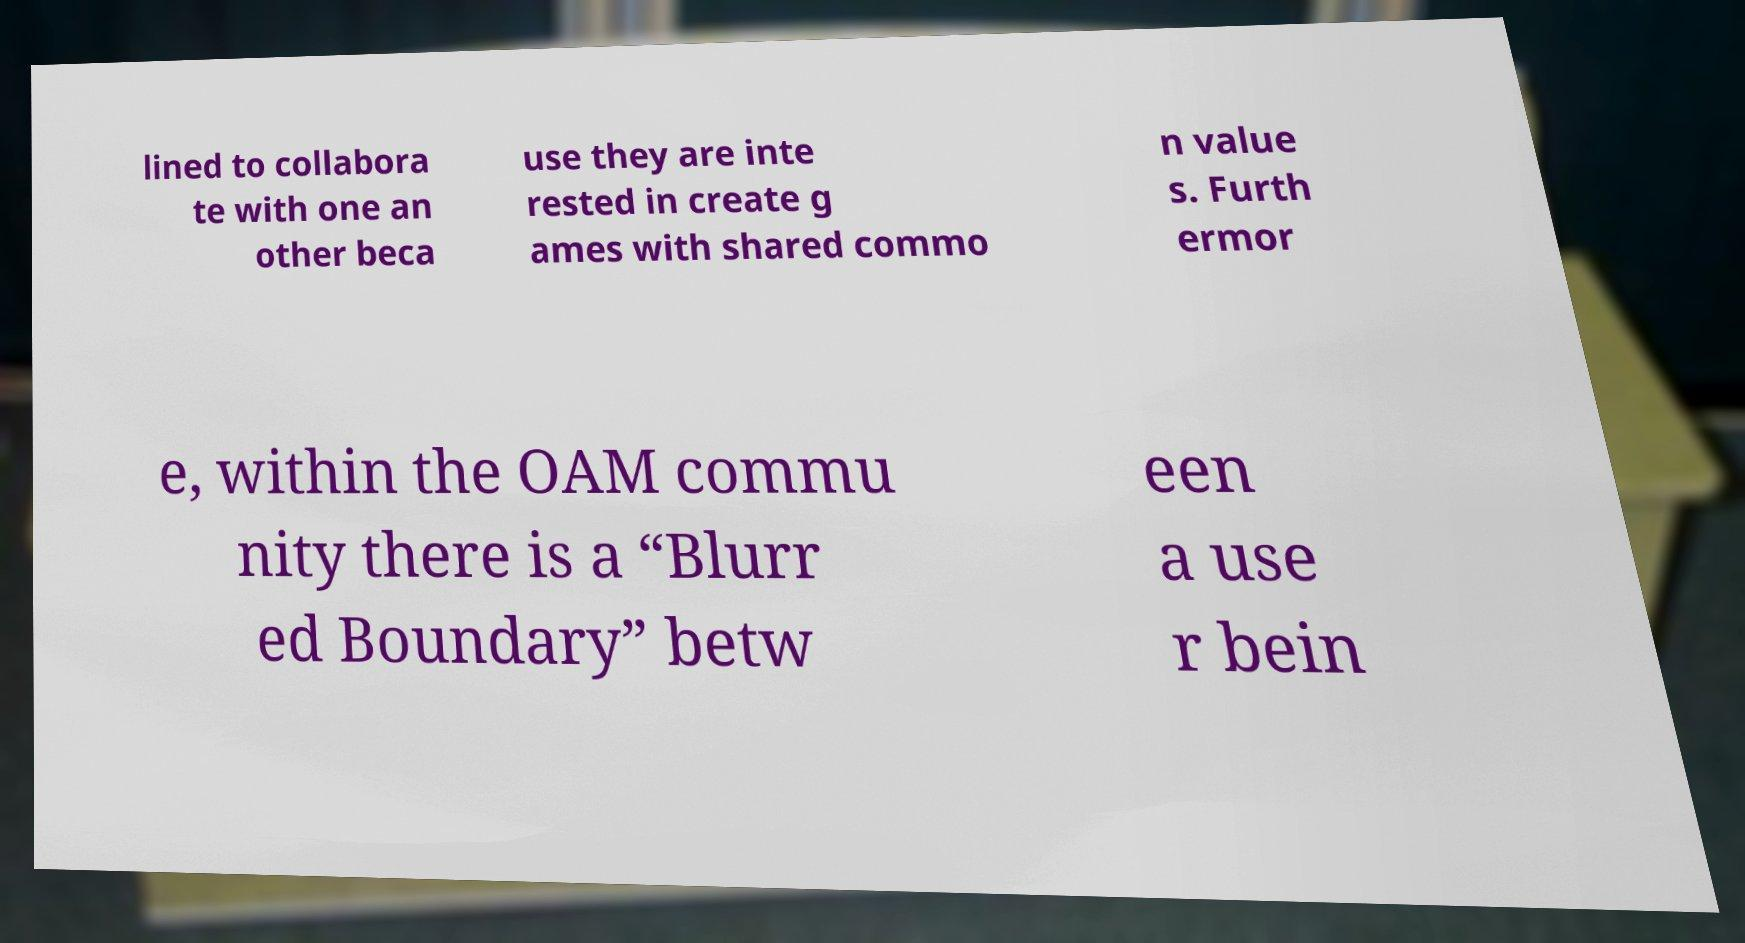What messages or text are displayed in this image? I need them in a readable, typed format. lined to collabora te with one an other beca use they are inte rested in create g ames with shared commo n value s. Furth ermor e, within the OAM commu nity there is a “Blurr ed Boundary” betw een a use r bein 